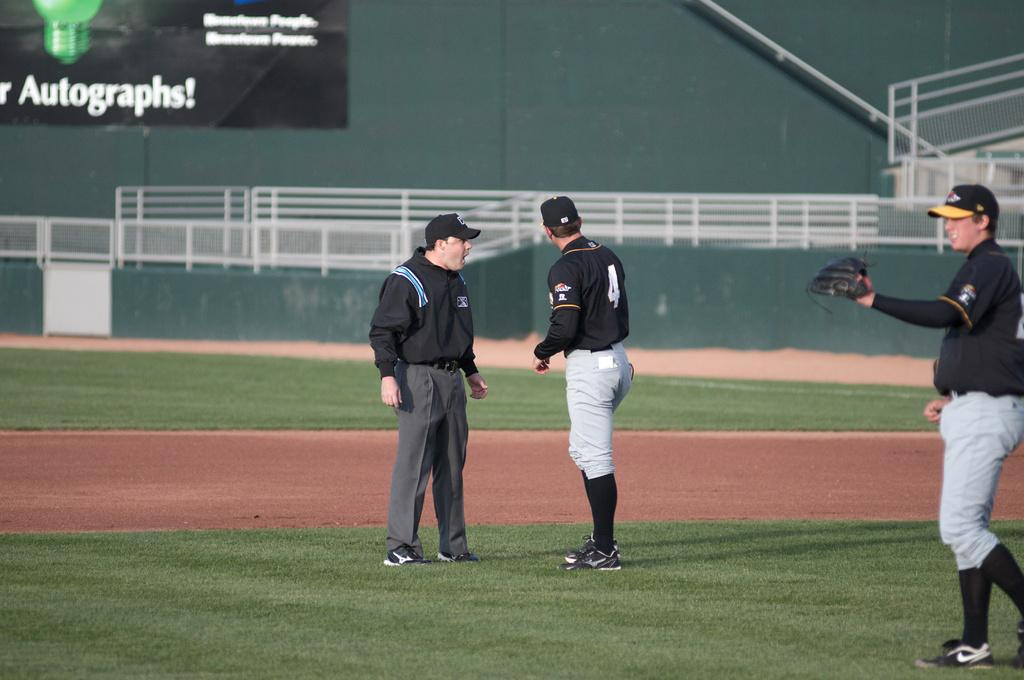<image>
Describe the image concisely. Three baseball players are talking on the field with one having the number 4 on his back. 